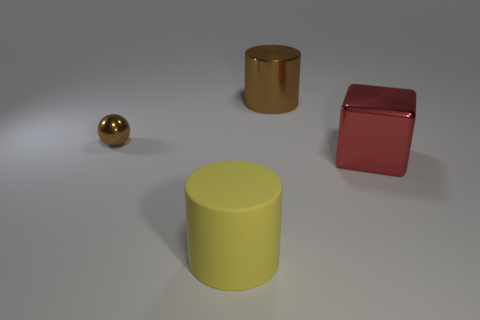Is there anything else that has the same size as the brown shiny cylinder?
Ensure brevity in your answer.  Yes. Do the small thing and the big cylinder in front of the tiny brown thing have the same material?
Keep it short and to the point. No. Is the color of the object that is in front of the large red thing the same as the big metallic cylinder?
Make the answer very short. No. The thing that is both in front of the tiny brown shiny ball and on the left side of the brown cylinder is made of what material?
Make the answer very short. Rubber. How big is the cube?
Make the answer very short. Large. Does the metal cylinder have the same color as the cylinder that is in front of the red block?
Keep it short and to the point. No. What number of other things are there of the same color as the shiny cylinder?
Provide a short and direct response. 1. There is a object in front of the big red block; is it the same size as the brown thing that is on the right side of the tiny ball?
Provide a short and direct response. Yes. The large thing in front of the block is what color?
Provide a short and direct response. Yellow. Is the number of big yellow rubber objects that are behind the cube less than the number of brown cylinders?
Offer a very short reply. Yes. 